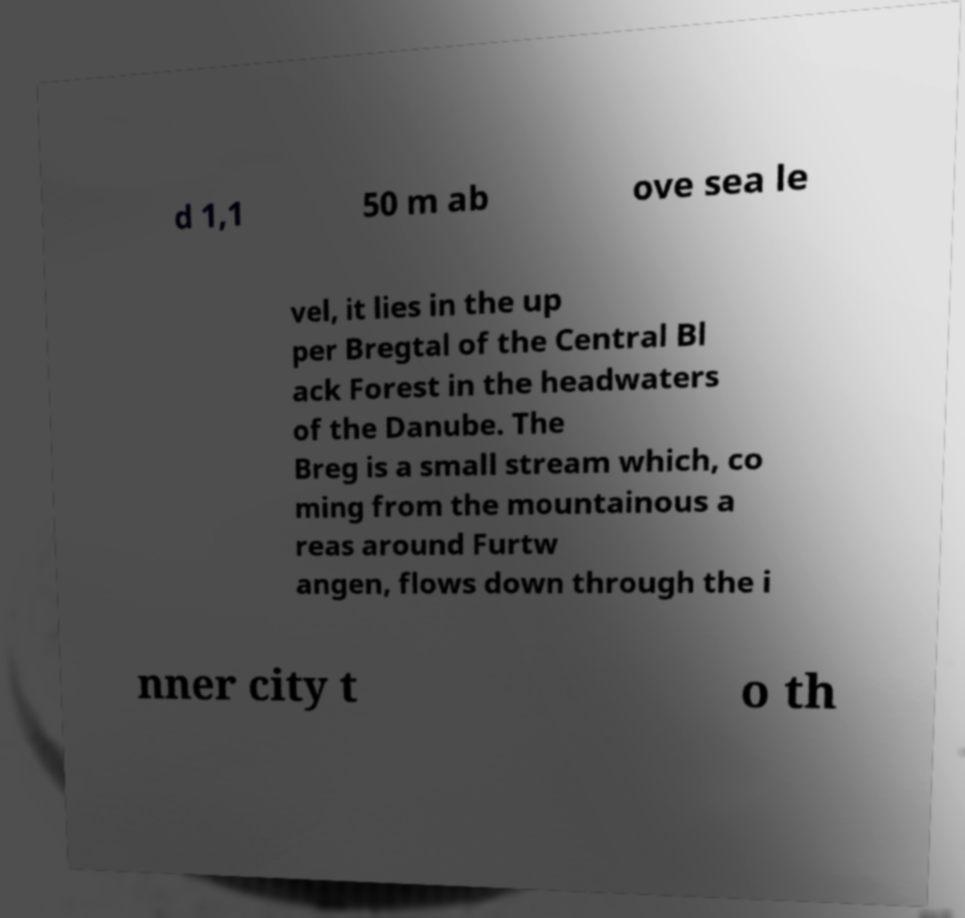Could you extract and type out the text from this image? d 1,1 50 m ab ove sea le vel, it lies in the up per Bregtal of the Central Bl ack Forest in the headwaters of the Danube. The Breg is a small stream which, co ming from the mountainous a reas around Furtw angen, flows down through the i nner city t o th 